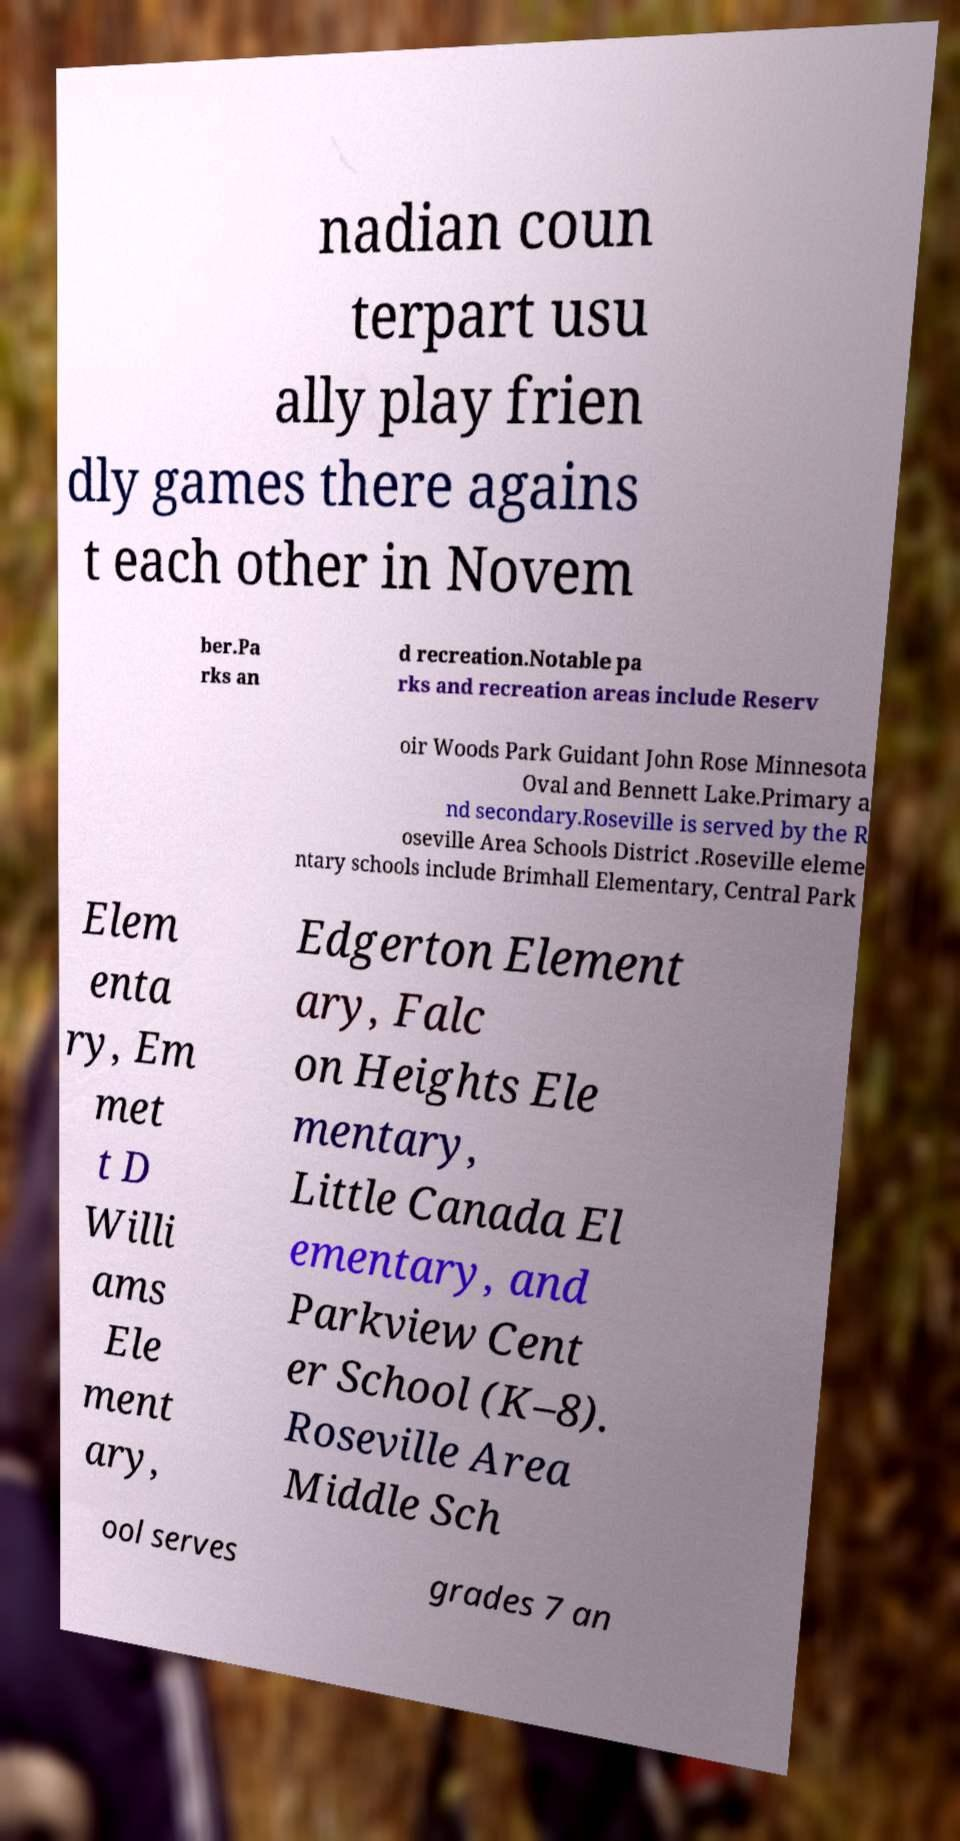Could you extract and type out the text from this image? nadian coun terpart usu ally play frien dly games there agains t each other in Novem ber.Pa rks an d recreation.Notable pa rks and recreation areas include Reserv oir Woods Park Guidant John Rose Minnesota Oval and Bennett Lake.Primary a nd secondary.Roseville is served by the R oseville Area Schools District .Roseville eleme ntary schools include Brimhall Elementary, Central Park Elem enta ry, Em met t D Willi ams Ele ment ary, Edgerton Element ary, Falc on Heights Ele mentary, Little Canada El ementary, and Parkview Cent er School (K–8). Roseville Area Middle Sch ool serves grades 7 an 